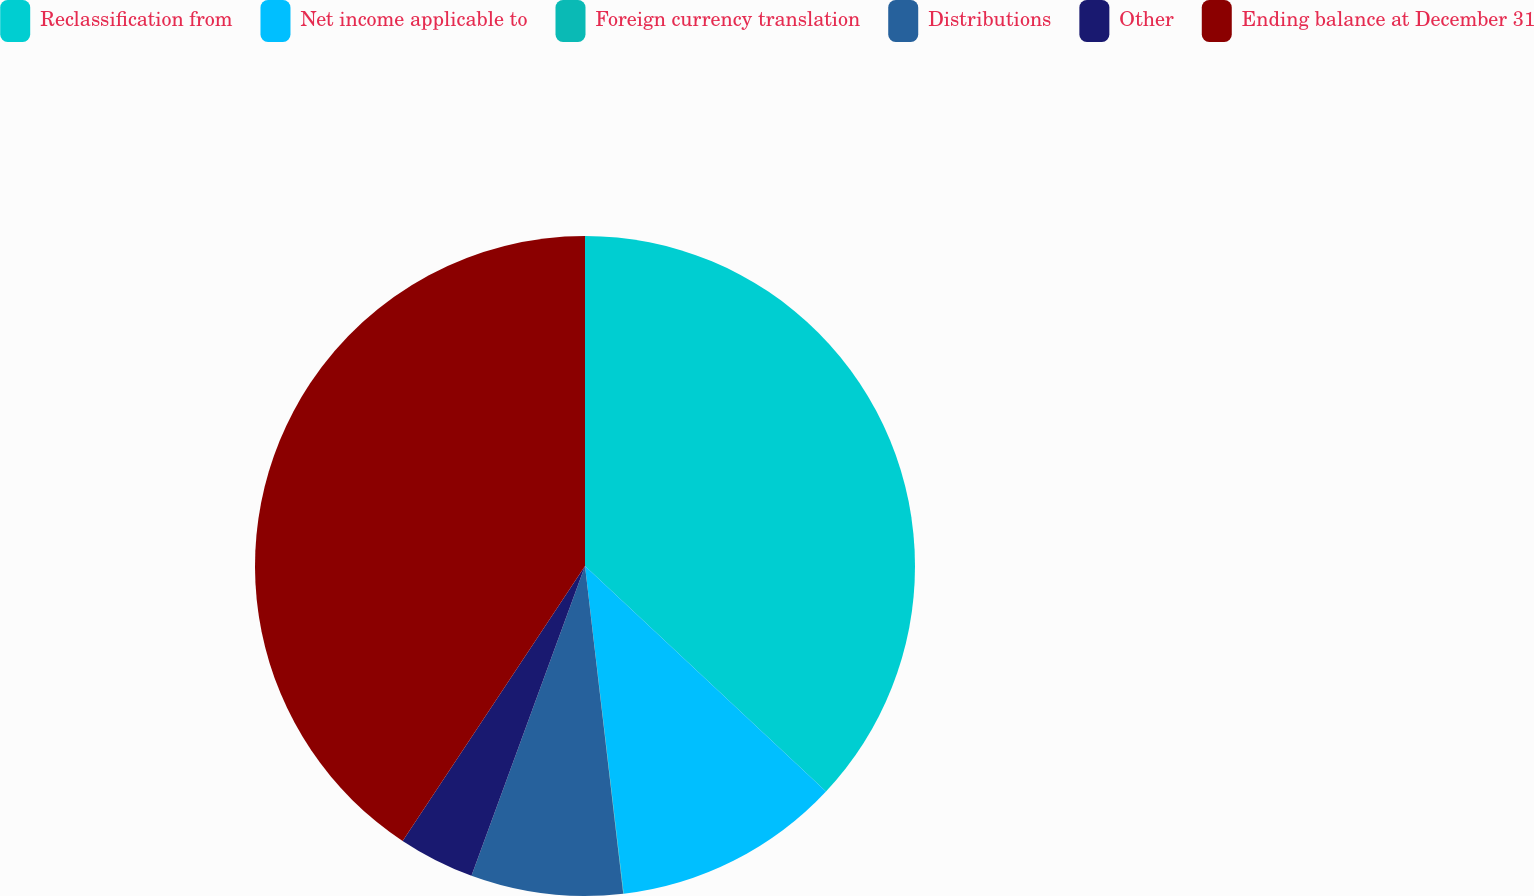Convert chart. <chart><loc_0><loc_0><loc_500><loc_500><pie_chart><fcel>Reclassification from<fcel>Net income applicable to<fcel>Foreign currency translation<fcel>Distributions<fcel>Other<fcel>Ending balance at December 31<nl><fcel>36.97%<fcel>11.16%<fcel>0.02%<fcel>7.44%<fcel>3.73%<fcel>40.68%<nl></chart> 